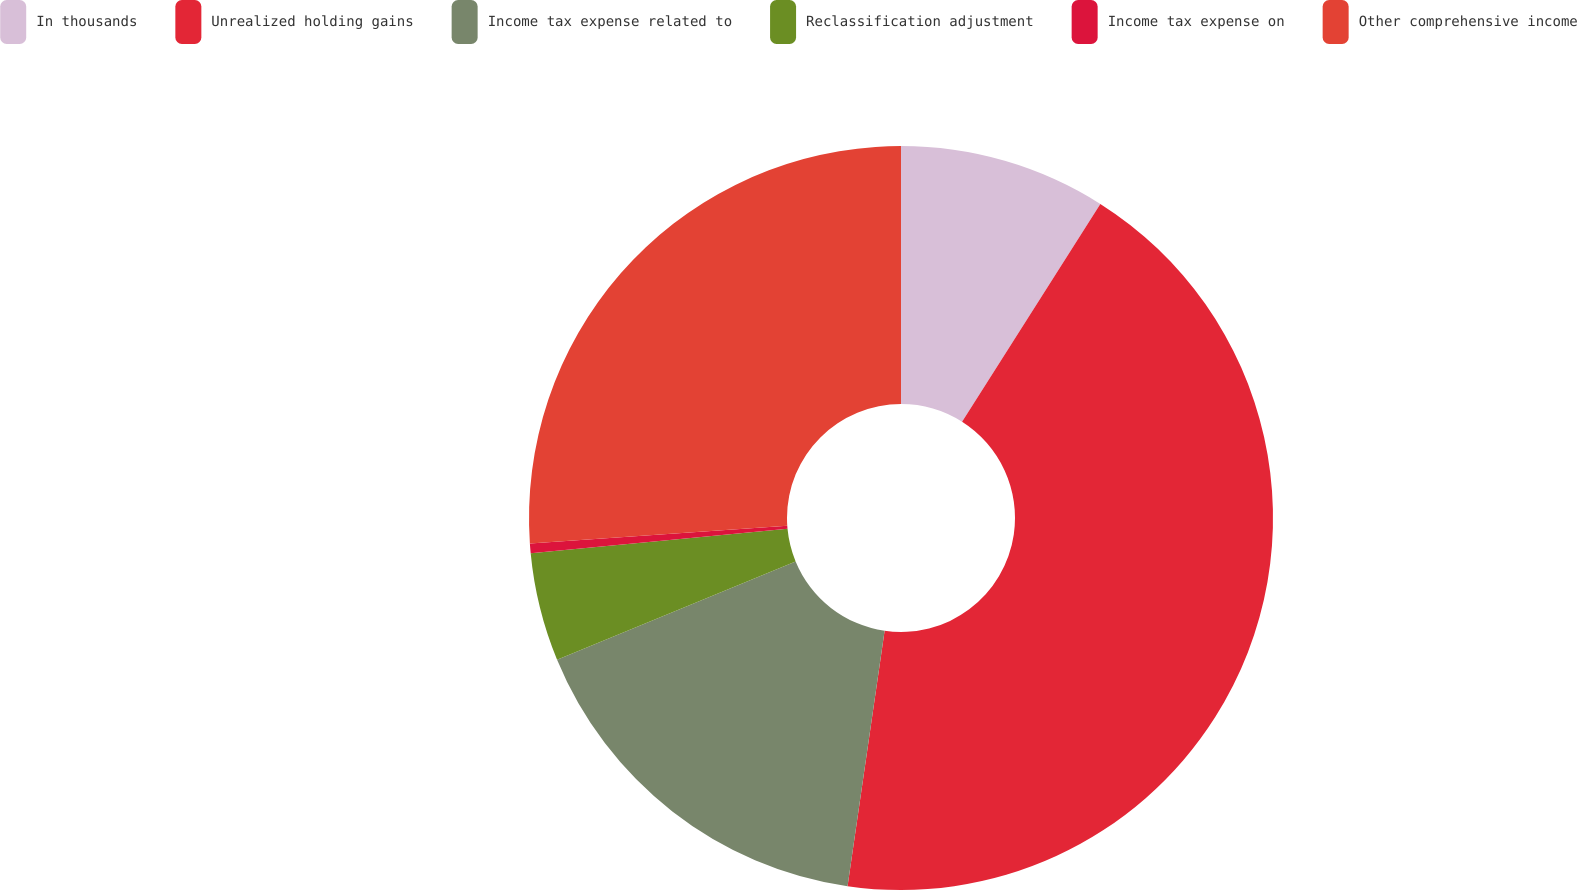Convert chart to OTSL. <chart><loc_0><loc_0><loc_500><loc_500><pie_chart><fcel>In thousands<fcel>Unrealized holding gains<fcel>Income tax expense related to<fcel>Reclassification adjustment<fcel>Income tax expense on<fcel>Other comprehensive income<nl><fcel>9.0%<fcel>43.29%<fcel>16.48%<fcel>4.71%<fcel>0.42%<fcel>26.09%<nl></chart> 